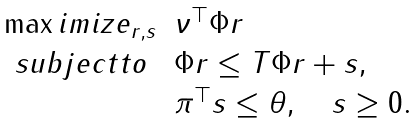<formula> <loc_0><loc_0><loc_500><loc_500>\begin{array} { l l l } \max i m i z e _ { r , s } & \nu ^ { \top } \Phi r \\ \ s u b j e c t t o & \Phi r \leq T \Phi r + s , \\ & \pi ^ { \top } s \leq \theta , \quad s \geq 0 . \end{array}</formula> 